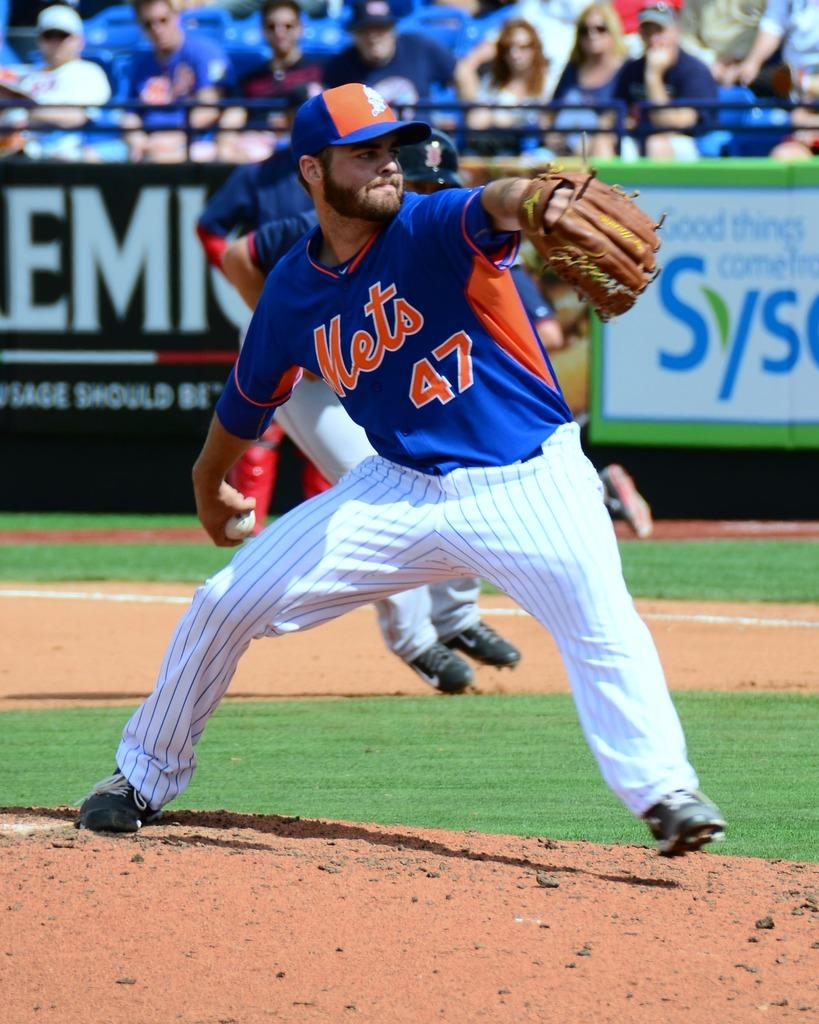<image>
Provide a brief description of the given image. A Mets baseball pitcher with #47 on his jersey is ready to throw a ball. 